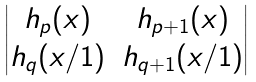Convert formula to latex. <formula><loc_0><loc_0><loc_500><loc_500>\begin{vmatrix} h _ { p } ( x ) & h _ { p + 1 } ( x ) \\ h _ { q } ( x / 1 ) & h _ { q + 1 } ( x / 1 ) \end{vmatrix}</formula> 